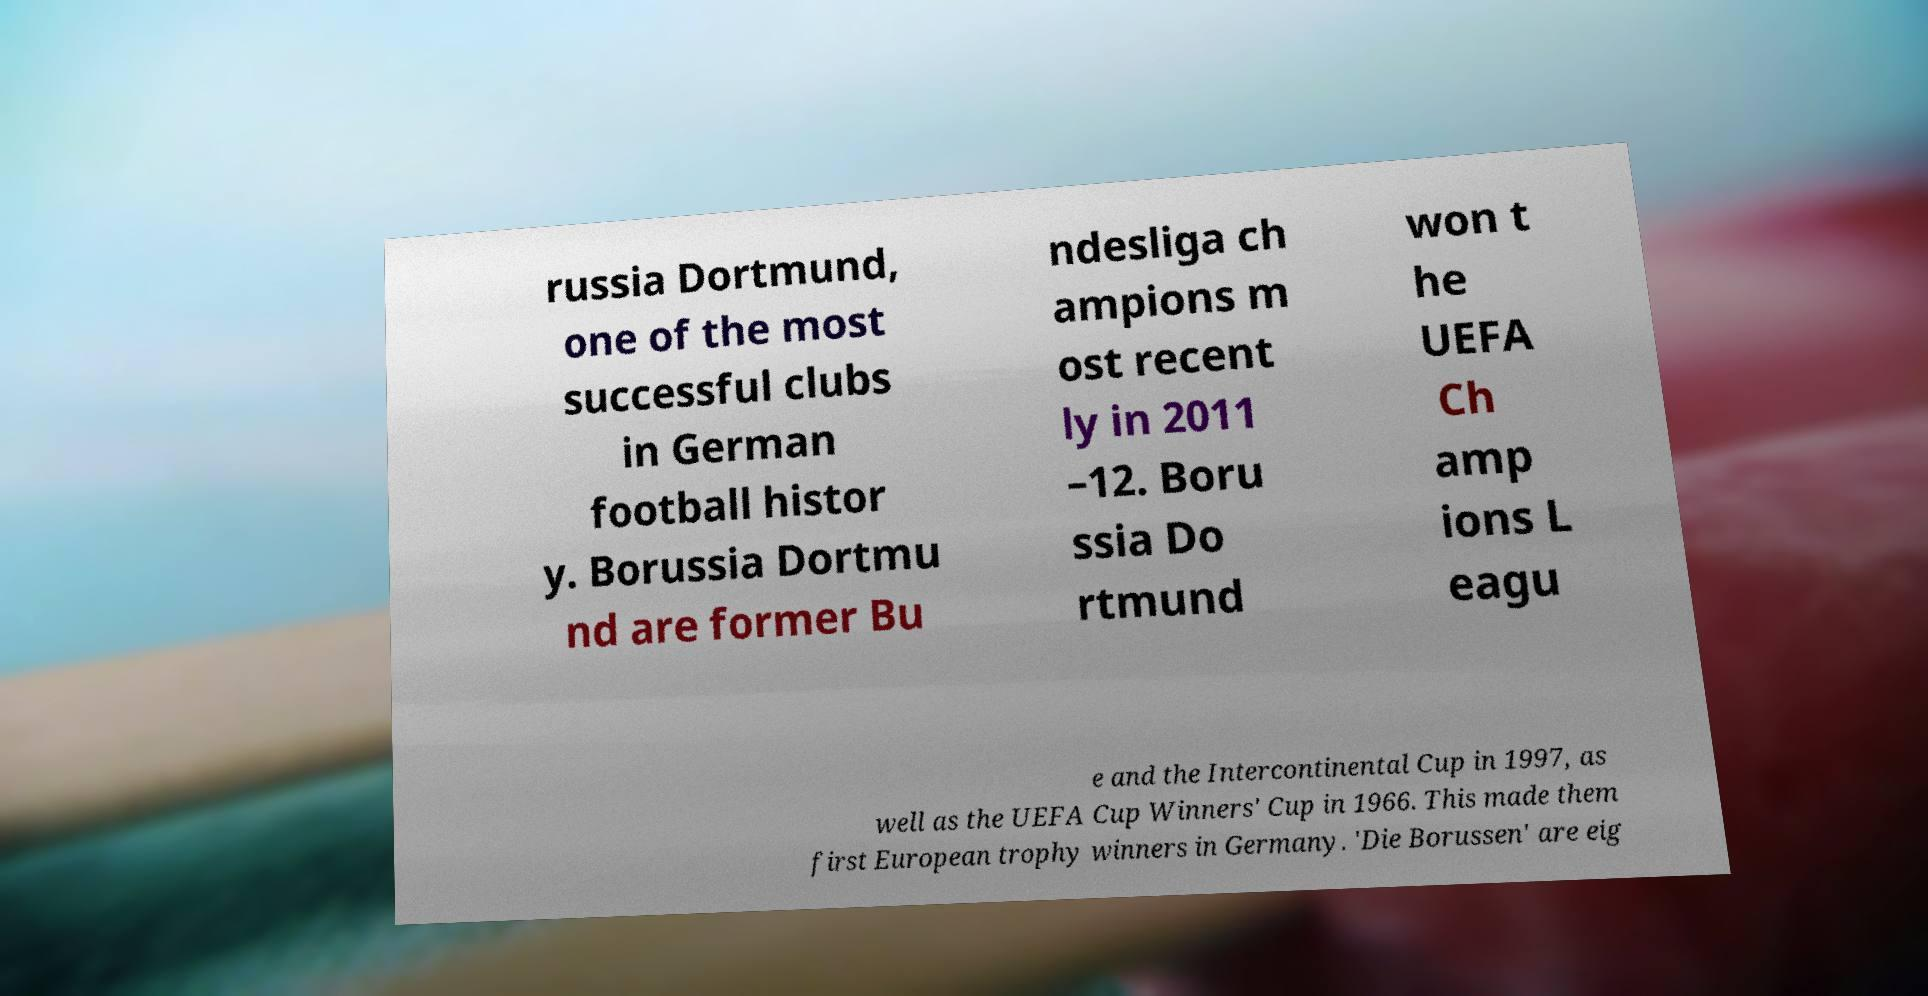For documentation purposes, I need the text within this image transcribed. Could you provide that? russia Dortmund, one of the most successful clubs in German football histor y. Borussia Dortmu nd are former Bu ndesliga ch ampions m ost recent ly in 2011 –12. Boru ssia Do rtmund won t he UEFA Ch amp ions L eagu e and the Intercontinental Cup in 1997, as well as the UEFA Cup Winners' Cup in 1966. This made them first European trophy winners in Germany. 'Die Borussen' are eig 